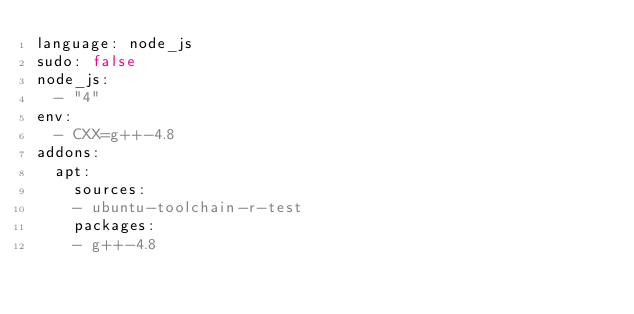<code> <loc_0><loc_0><loc_500><loc_500><_YAML_>language: node_js
sudo: false
node_js:
  - "4"
env:
  - CXX=g++-4.8
addons:
  apt:
    sources:
    - ubuntu-toolchain-r-test
    packages:
    - g++-4.8
</code> 